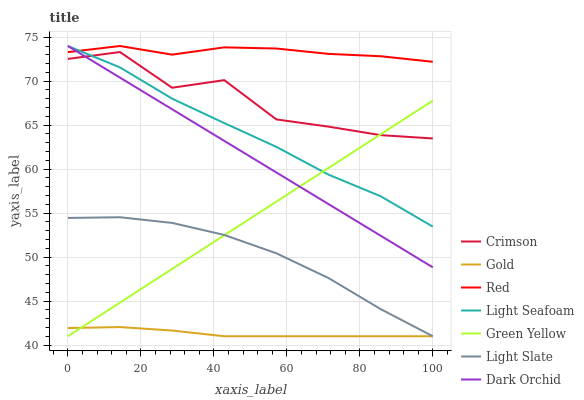Does Gold have the minimum area under the curve?
Answer yes or no. Yes. Does Red have the maximum area under the curve?
Answer yes or no. Yes. Does Light Slate have the minimum area under the curve?
Answer yes or no. No. Does Light Slate have the maximum area under the curve?
Answer yes or no. No. Is Dark Orchid the smoothest?
Answer yes or no. Yes. Is Crimson the roughest?
Answer yes or no. Yes. Is Gold the smoothest?
Answer yes or no. No. Is Gold the roughest?
Answer yes or no. No. Does Gold have the lowest value?
Answer yes or no. Yes. Does Dark Orchid have the lowest value?
Answer yes or no. No. Does Red have the highest value?
Answer yes or no. Yes. Does Light Slate have the highest value?
Answer yes or no. No. Is Light Slate less than Crimson?
Answer yes or no. Yes. Is Red greater than Crimson?
Answer yes or no. Yes. Does Light Slate intersect Green Yellow?
Answer yes or no. Yes. Is Light Slate less than Green Yellow?
Answer yes or no. No. Is Light Slate greater than Green Yellow?
Answer yes or no. No. Does Light Slate intersect Crimson?
Answer yes or no. No. 